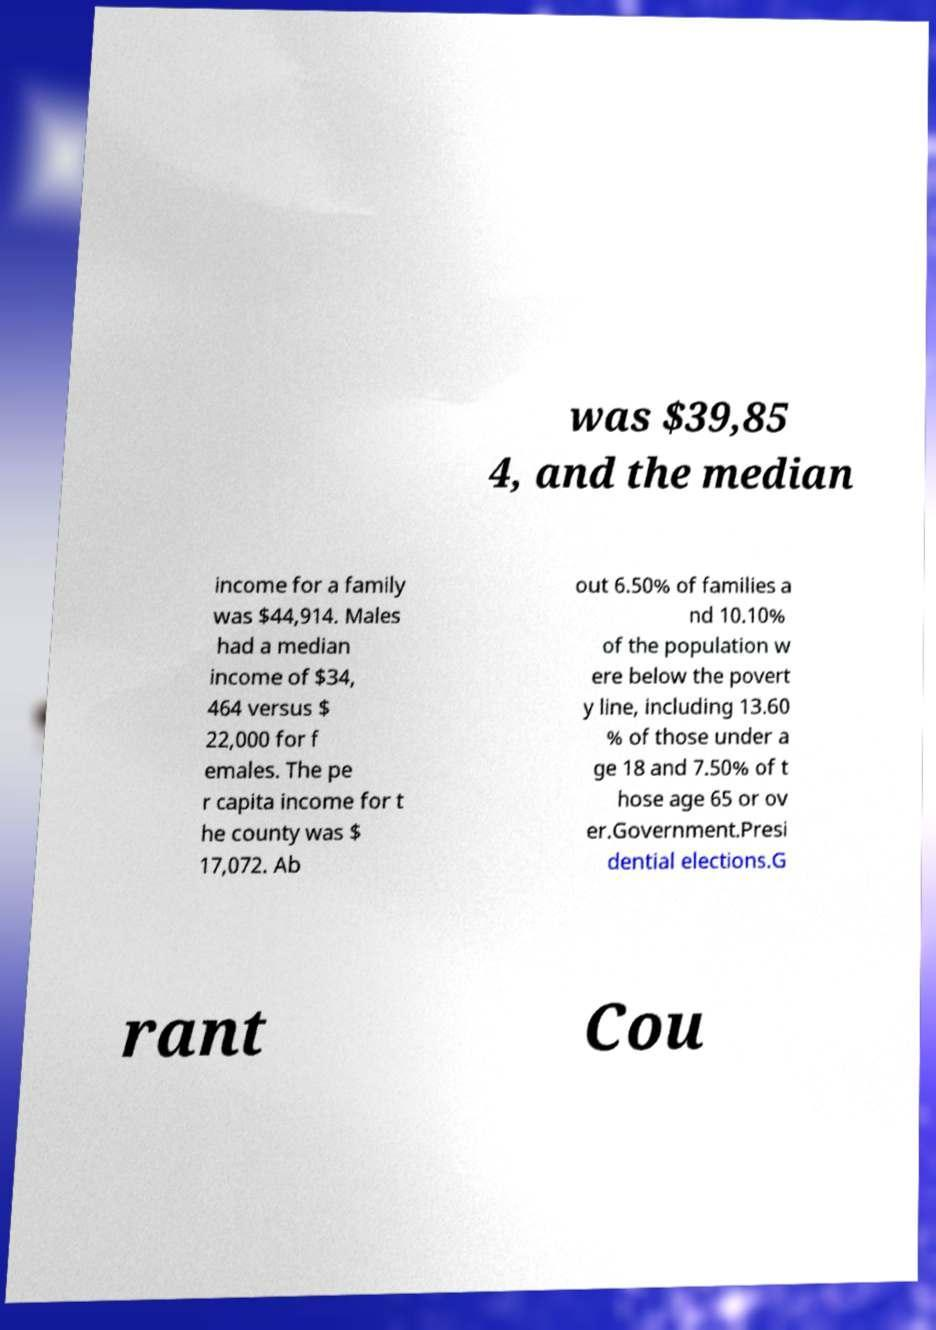Can you read and provide the text displayed in the image?This photo seems to have some interesting text. Can you extract and type it out for me? was $39,85 4, and the median income for a family was $44,914. Males had a median income of $34, 464 versus $ 22,000 for f emales. The pe r capita income for t he county was $ 17,072. Ab out 6.50% of families a nd 10.10% of the population w ere below the povert y line, including 13.60 % of those under a ge 18 and 7.50% of t hose age 65 or ov er.Government.Presi dential elections.G rant Cou 